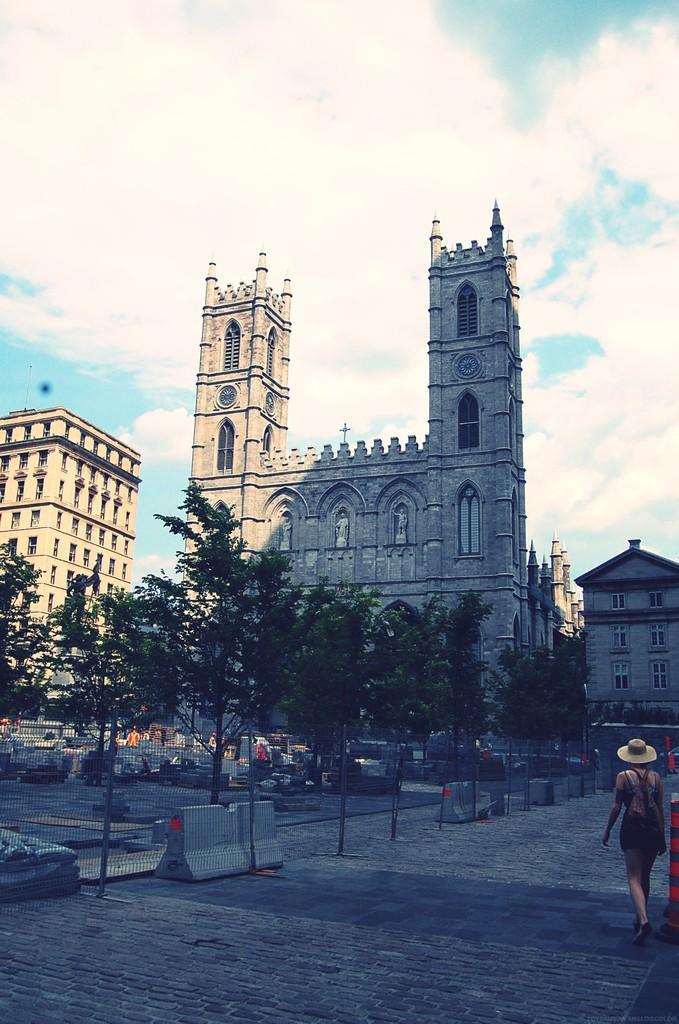Can you describe this image briefly? In this image we can see a person wearing a hat and carrying bag is standing on the ground. In the center of the image we can see a group of trees and barricades. In the background, we can see a group of buildings with windows, towers and the cloudy sky. 